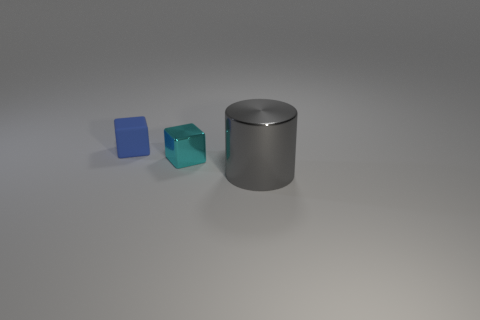Is there anything else that is the same size as the cyan metallic cube?
Your answer should be compact. Yes. What number of other things are there of the same shape as the gray metal thing?
Your answer should be very brief. 0. Is the blue rubber block the same size as the gray shiny cylinder?
Your response must be concise. No. Is there a metal cube?
Your answer should be compact. Yes. Is there anything else that has the same material as the tiny cyan cube?
Provide a short and direct response. Yes. Is there a tiny blue block made of the same material as the big cylinder?
Your answer should be compact. No. There is a blue object that is the same size as the cyan shiny object; what is its material?
Provide a short and direct response. Rubber. What number of tiny blue rubber objects have the same shape as the cyan shiny thing?
Ensure brevity in your answer.  1. There is a cube that is made of the same material as the large cylinder; what is its size?
Provide a short and direct response. Small. What is the material of the thing that is right of the blue matte cube and behind the big object?
Provide a succinct answer. Metal. 